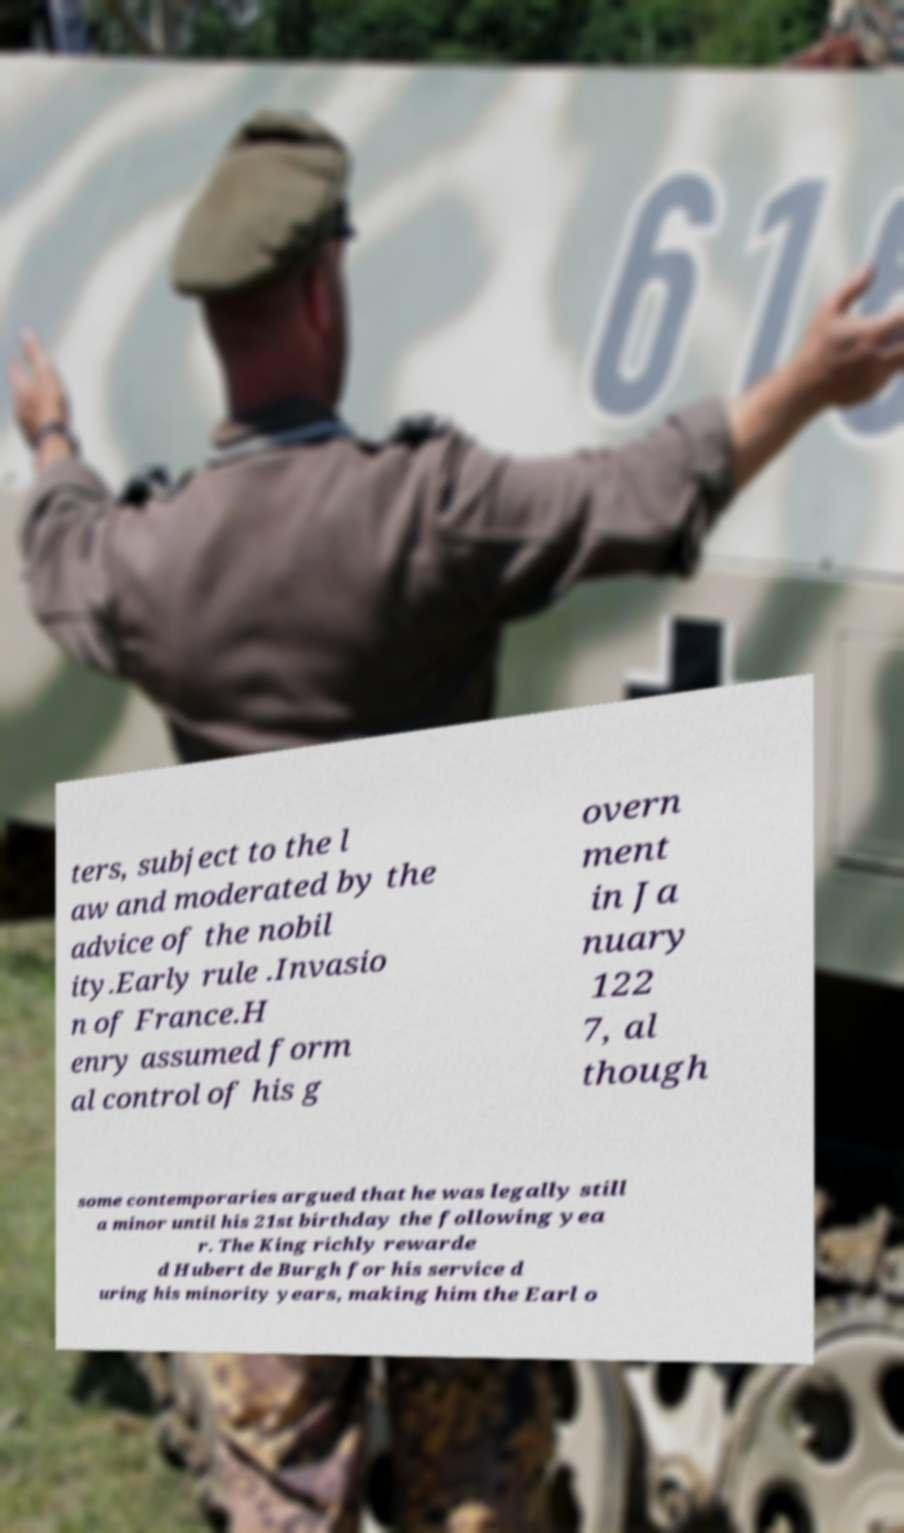Could you assist in decoding the text presented in this image and type it out clearly? ters, subject to the l aw and moderated by the advice of the nobil ity.Early rule .Invasio n of France.H enry assumed form al control of his g overn ment in Ja nuary 122 7, al though some contemporaries argued that he was legally still a minor until his 21st birthday the following yea r. The King richly rewarde d Hubert de Burgh for his service d uring his minority years, making him the Earl o 